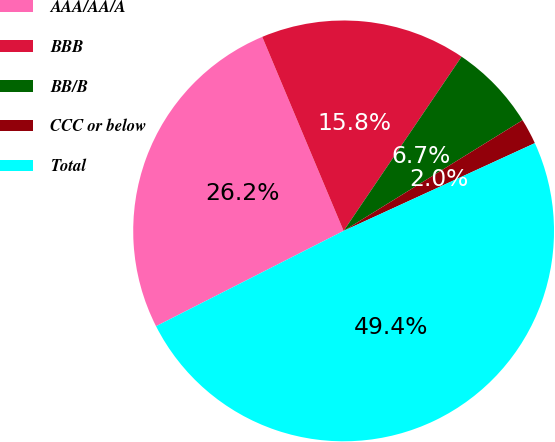<chart> <loc_0><loc_0><loc_500><loc_500><pie_chart><fcel>AAA/AA/A<fcel>BBB<fcel>BB/B<fcel>CCC or below<fcel>Total<nl><fcel>26.16%<fcel>15.79%<fcel>6.71%<fcel>1.97%<fcel>49.36%<nl></chart> 